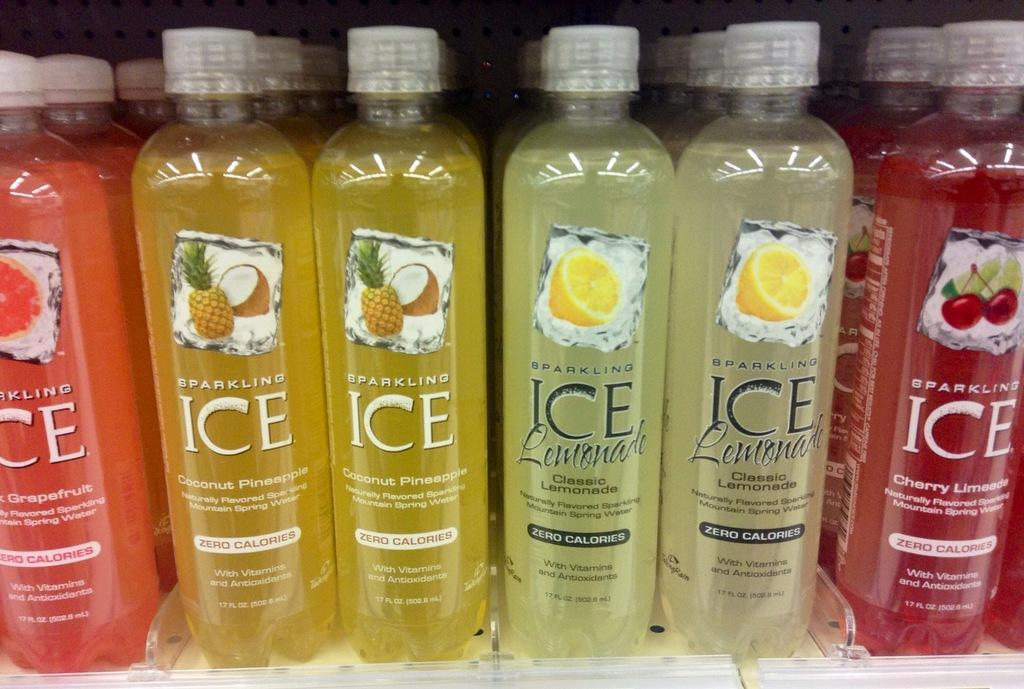<image>
Summarize the visual content of the image. several containers of sparkling ice liquids in many colors 